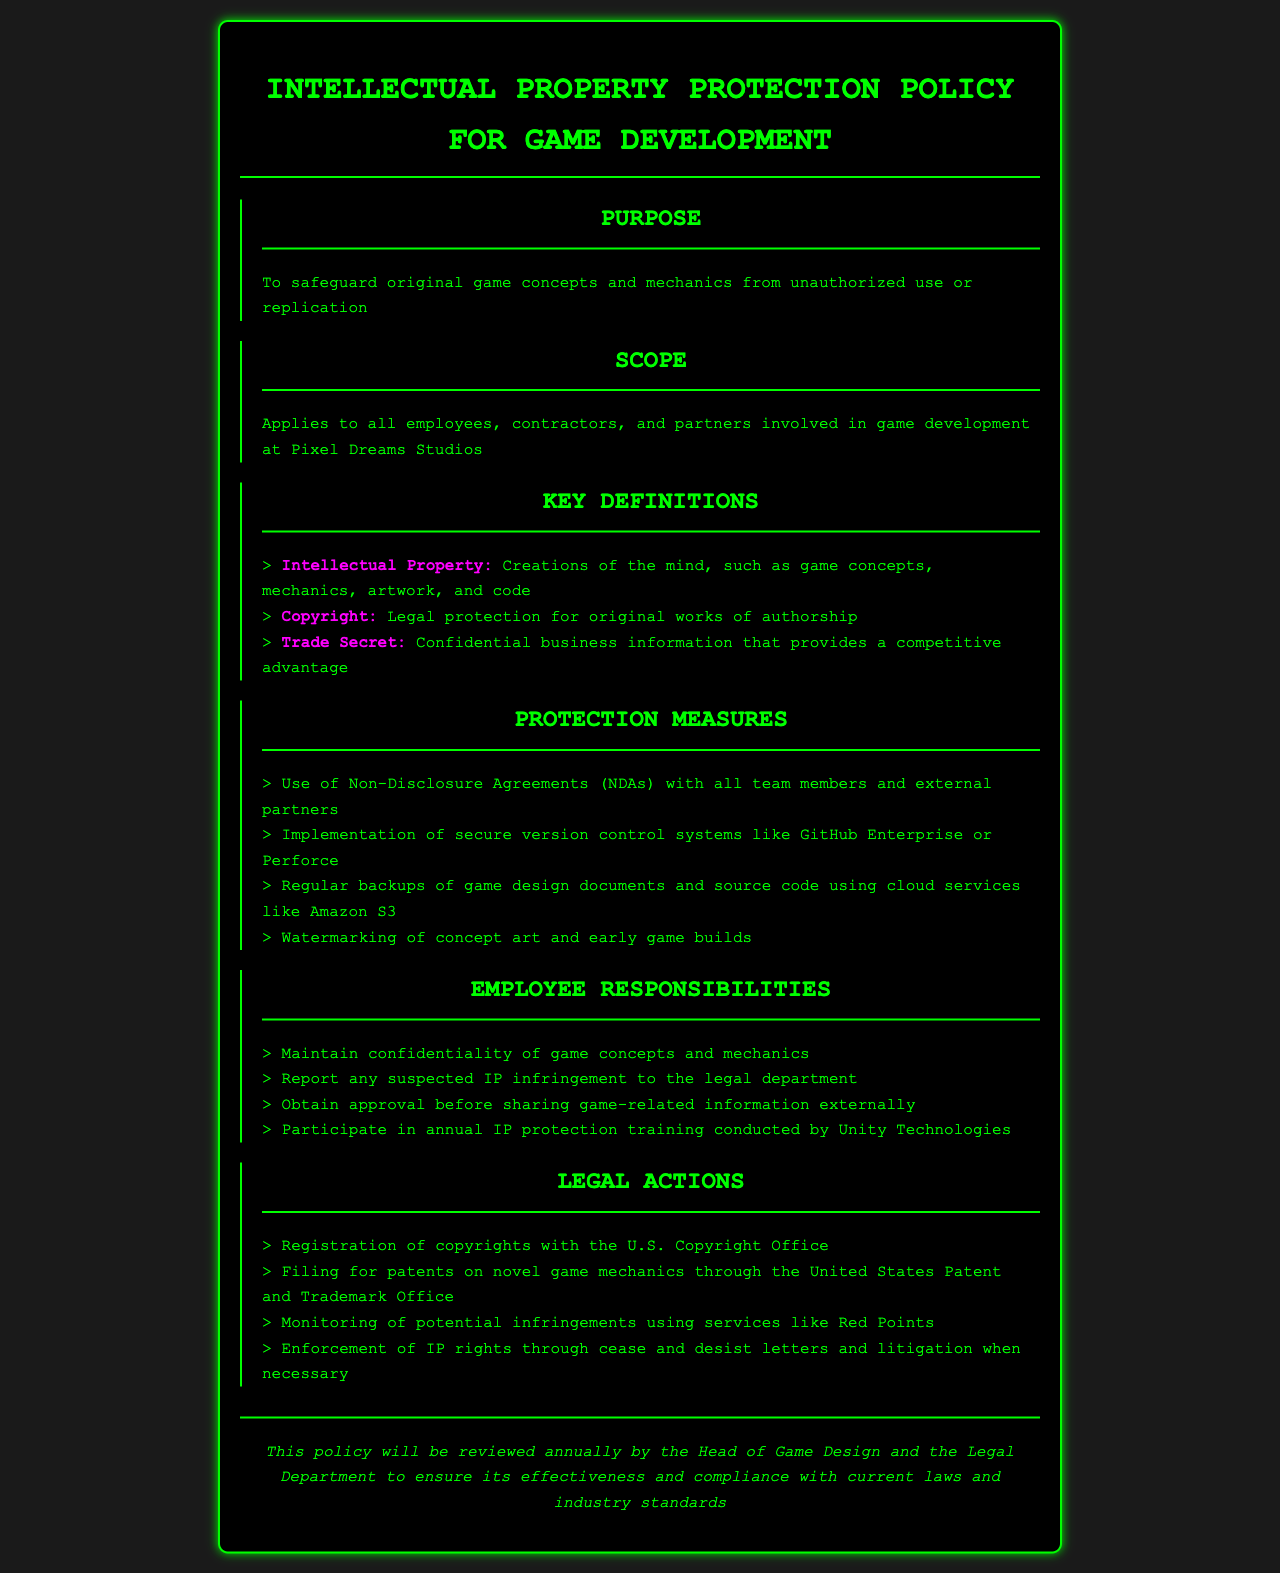What is the purpose of the policy? The purpose of the policy is to safeguard original game concepts and mechanics from unauthorized use or replication.
Answer: Safeguard original game concepts and mechanics from unauthorized use or replication Who does the policy apply to? The policy applies to all employees, contractors, and partners involved in game development at Pixel Dreams Studios.
Answer: All employees, contractors, and partners involved in game development at Pixel Dreams Studios What is one key definition of Intellectual Property? Intellectual Property is defined as creations of the mind, such as game concepts, mechanics, artwork, and code.
Answer: Creations of the mind, such as game concepts, mechanics, artwork, and code What is one protection measure mentioned in the document? One of the protection measures mentioned is the use of Non-Disclosure Agreements (NDAs) with all team members and external partners.
Answer: Use of Non-Disclosure Agreements (NDAs) with all team members and external partners How often will the policy be reviewed? The policy will be reviewed annually by the Head of Game Design and the Legal Department.
Answer: Annually What is required of employees regarding game concepts? Employees are required to maintain confidentiality of game concepts and mechanics.
Answer: Maintain confidentiality of game concepts and mechanics Where should suspected IP infringement be reported? Suspected IP infringement should be reported to the legal department.
Answer: Legal department What is one legal action mentioned in the policy? A legal action mentioned is the registration of copyrights with the U.S. Copyright Office.
Answer: Registration of copyrights with the U.S. Copyright Office 